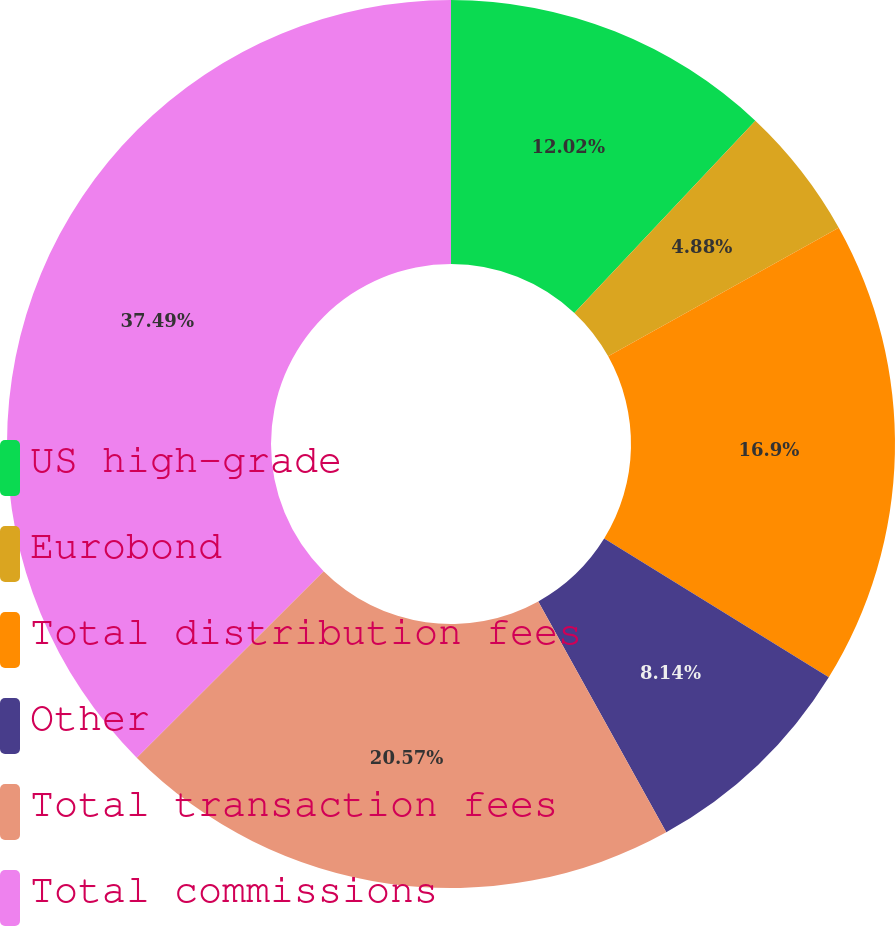Convert chart. <chart><loc_0><loc_0><loc_500><loc_500><pie_chart><fcel>US high-grade<fcel>Eurobond<fcel>Total distribution fees<fcel>Other<fcel>Total transaction fees<fcel>Total commissions<nl><fcel>12.02%<fcel>4.88%<fcel>16.9%<fcel>8.14%<fcel>20.57%<fcel>37.48%<nl></chart> 